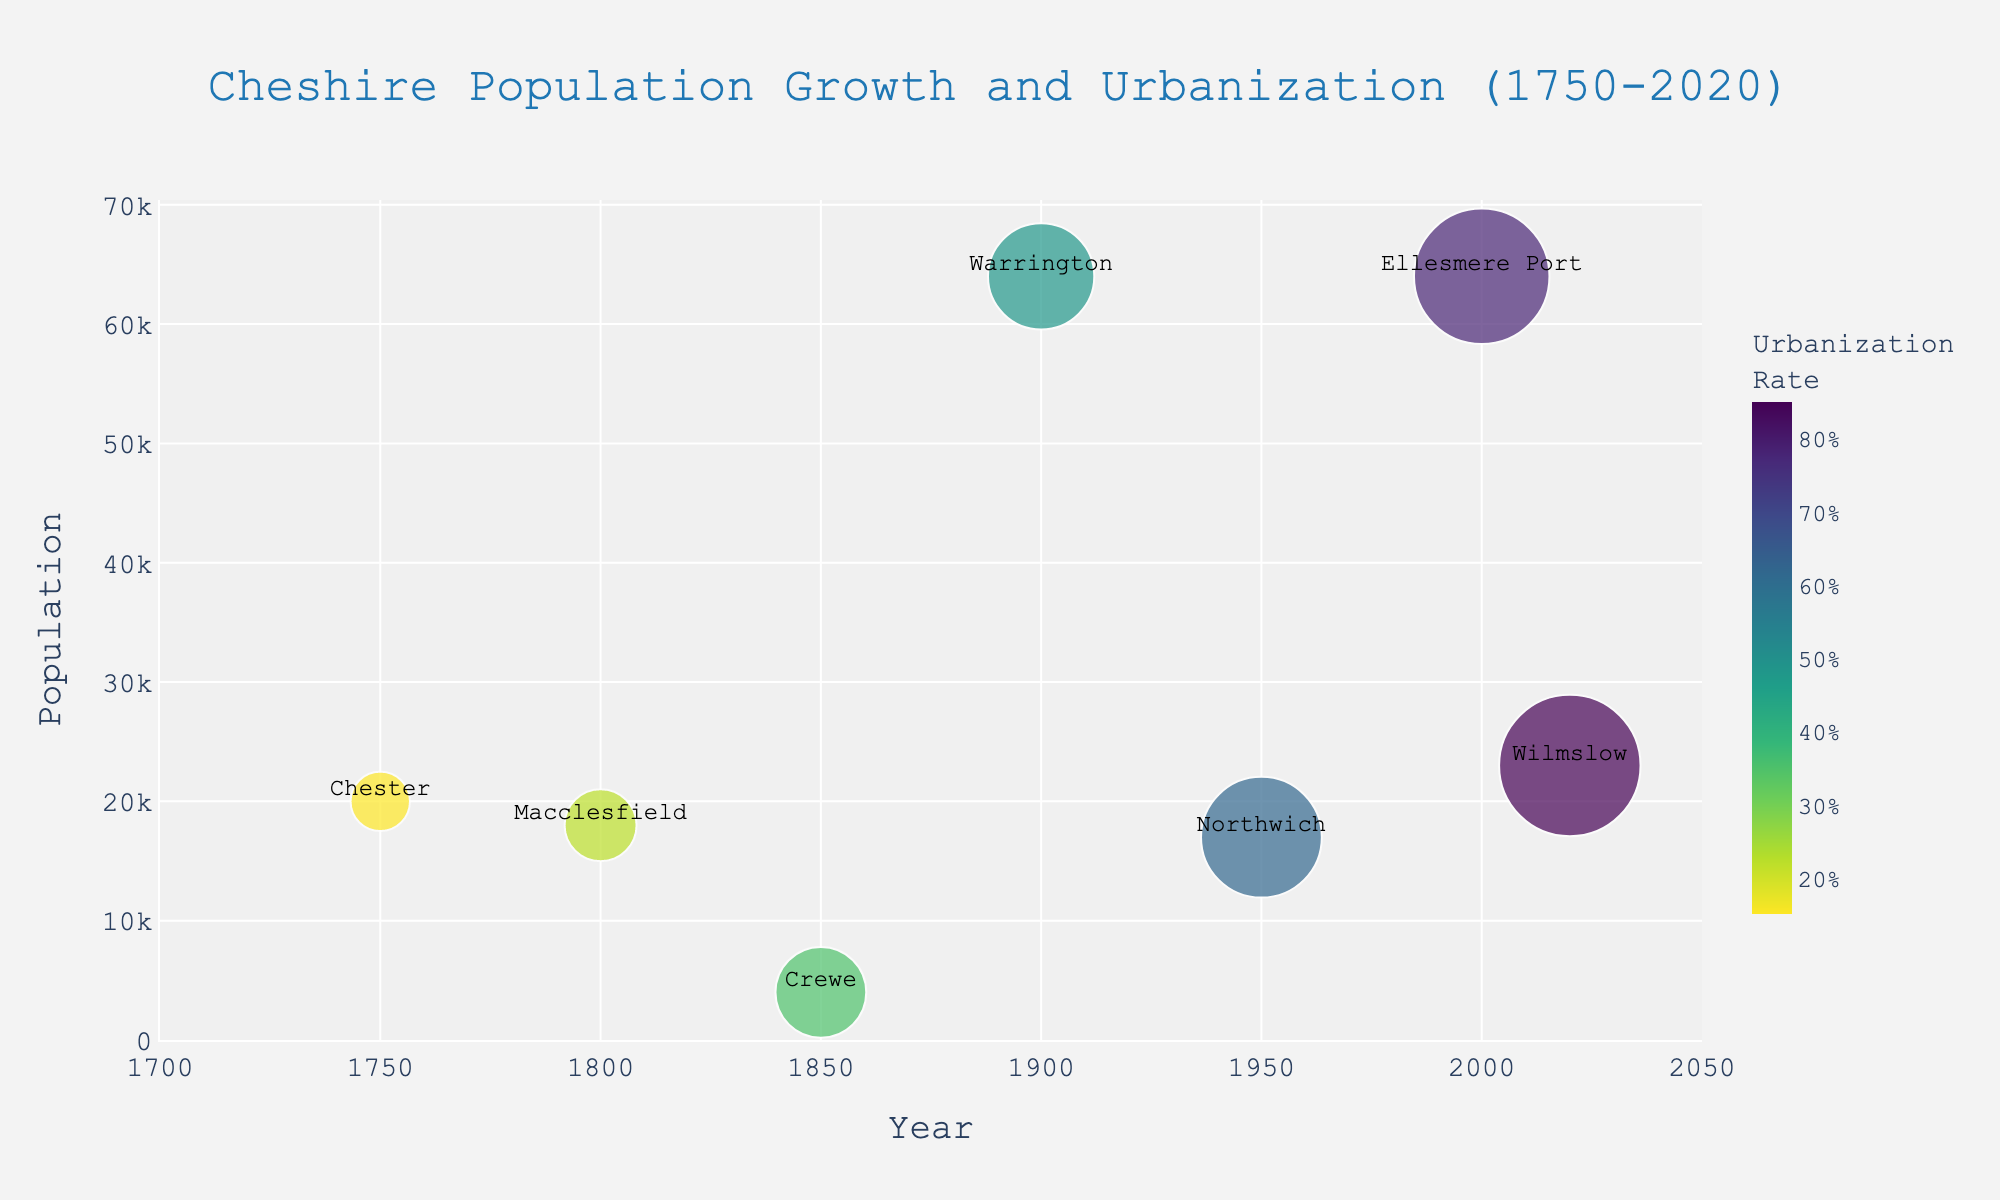What's the title of the plot? The title is displayed at the top of the plot. It reads "Cheshire Population Growth and Urbanization (1750-2020)."
Answer: Cheshire Population Growth and Urbanization (1750-2020) Which location had the highest population in 1900? By looking at the data points for the year 1900, the location with the highest population is Warrington with a population of 64,000.
Answer: Warrington How many data points are there in the plot? Each year-location combination represents a data point. Counting them, there are seven data points in the plot.
Answer: Seven Which year had the highest urbanization rate according to the plot? The year with the highest urbanization rate is presented by the largest bubble size and the darkest color. This is the year 2020, with an urbanization rate of 0.85.
Answer: 2020 What is the difference in population between Wilmslow in 2020 and Macclesfield in 1800? The population of Wilmslow in 2020 is 23,000 and Macclesfield in 1800 is 18,000. The difference is 23,000 - 18,000 = 5,000.
Answer: 5,000 Which location experienced the highest population growth between 1950 and 2000? By examining the population values, Ellesmere Port had a population of 17,000 in 1950 and 64,000 in 2000. The growth is 64,000 - 17,000 = 47,000. This is the highest growth in that timeframe.
Answer: Ellesmere Port Is there a location where the urbanization rate is higher than 0.60 but the population is less than 20,000? Northwich in 1950 has an urbanization rate of 0.62 and a population of 17,000, which fits the given criteria.
Answer: Northwich Which location had the lowest population recorded in the plot? Crewe in 1850 has the lowest population in the plot with just 4,000 people.
Answer: Crewe What is the urbanization rate in Ellesmere Port in the year 2000? The bubble for Ellesmere Port in the year 2000 represents an urbanization rate of 0.78, as indicated in the plot.
Answer: 0.78 